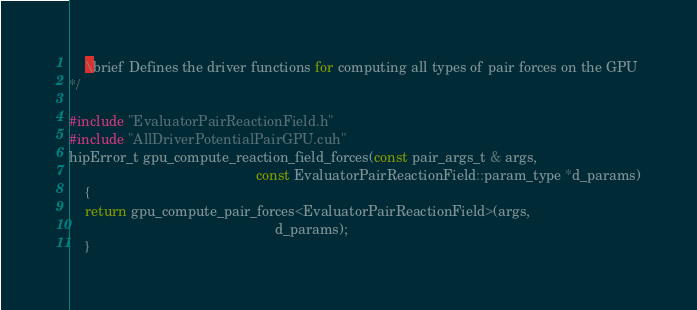Convert code to text. <code><loc_0><loc_0><loc_500><loc_500><_Cuda_>    \brief Defines the driver functions for computing all types of pair forces on the GPU
*/

#include "EvaluatorPairReactionField.h"
#include "AllDriverPotentialPairGPU.cuh"
hipError_t gpu_compute_reaction_field_forces(const pair_args_t & args,
                                                const EvaluatorPairReactionField::param_type *d_params)
    {
    return gpu_compute_pair_forces<EvaluatorPairReactionField>(args,
                                                     d_params);
    }

</code> 